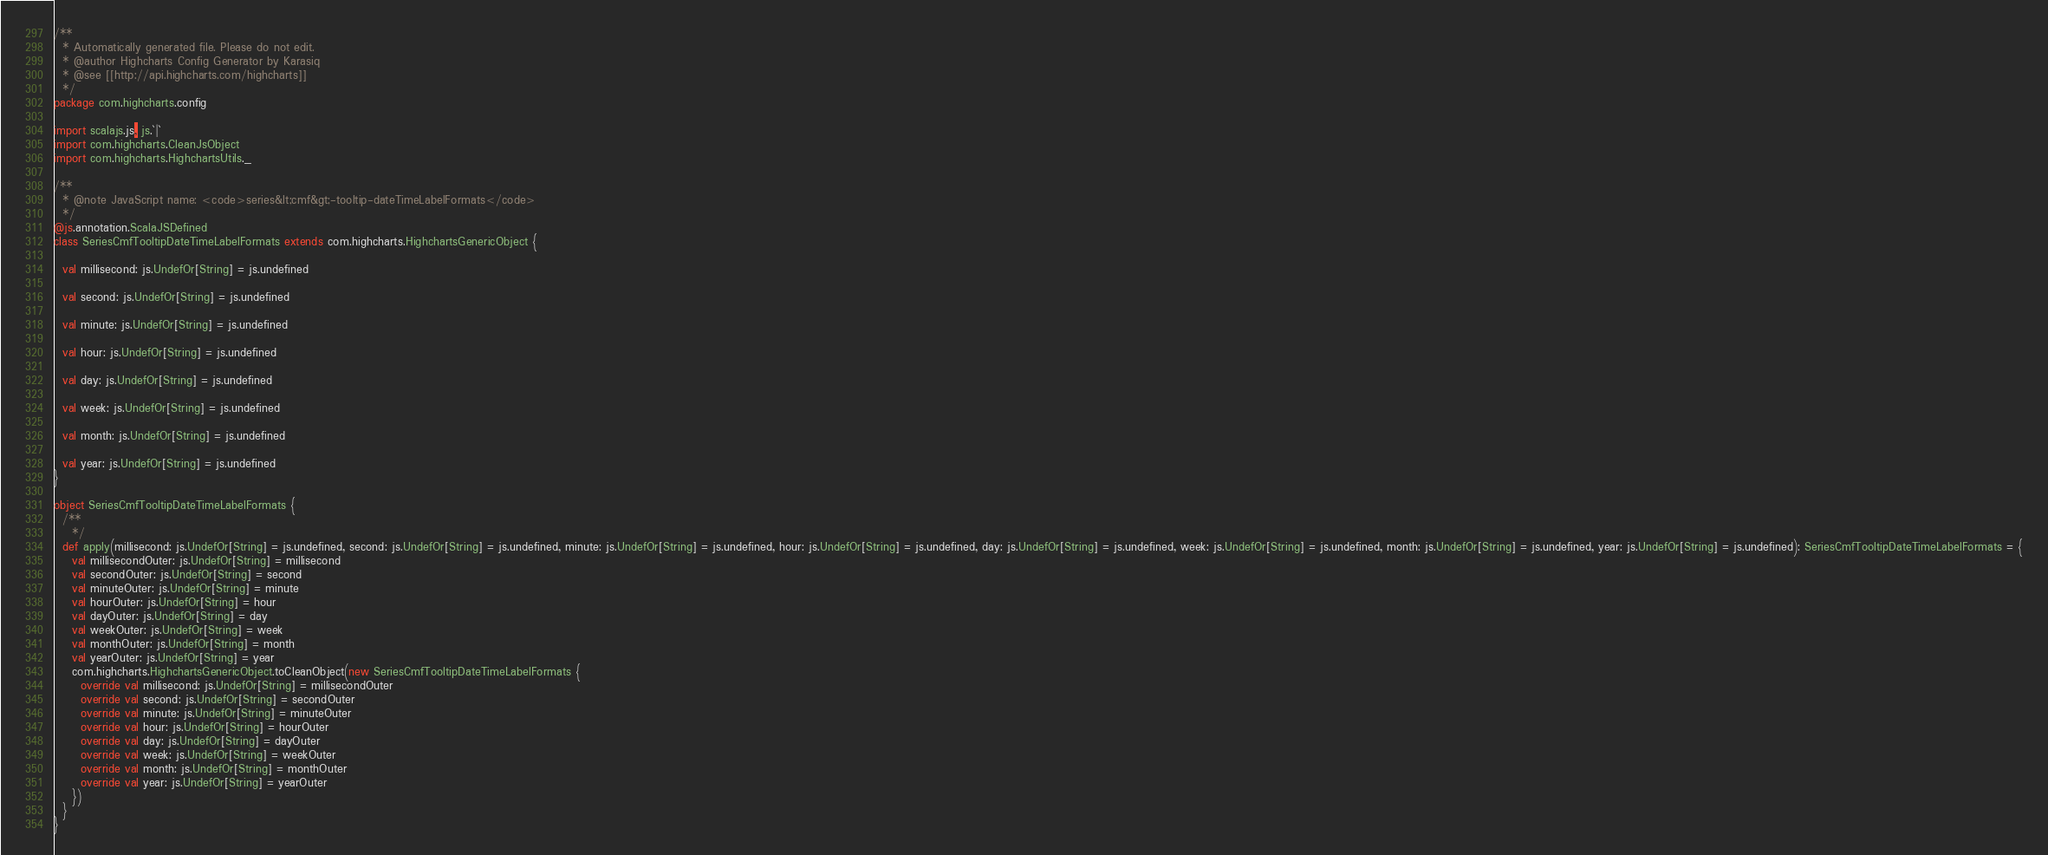Convert code to text. <code><loc_0><loc_0><loc_500><loc_500><_Scala_>/**
  * Automatically generated file. Please do not edit.
  * @author Highcharts Config Generator by Karasiq
  * @see [[http://api.highcharts.com/highcharts]]
  */
package com.highcharts.config

import scalajs.js, js.`|`
import com.highcharts.CleanJsObject
import com.highcharts.HighchartsUtils._

/**
  * @note JavaScript name: <code>series&lt;cmf&gt;-tooltip-dateTimeLabelFormats</code>
  */
@js.annotation.ScalaJSDefined
class SeriesCmfTooltipDateTimeLabelFormats extends com.highcharts.HighchartsGenericObject {

  val millisecond: js.UndefOr[String] = js.undefined

  val second: js.UndefOr[String] = js.undefined

  val minute: js.UndefOr[String] = js.undefined

  val hour: js.UndefOr[String] = js.undefined

  val day: js.UndefOr[String] = js.undefined

  val week: js.UndefOr[String] = js.undefined

  val month: js.UndefOr[String] = js.undefined

  val year: js.UndefOr[String] = js.undefined
}

object SeriesCmfTooltipDateTimeLabelFormats {
  /**
    */
  def apply(millisecond: js.UndefOr[String] = js.undefined, second: js.UndefOr[String] = js.undefined, minute: js.UndefOr[String] = js.undefined, hour: js.UndefOr[String] = js.undefined, day: js.UndefOr[String] = js.undefined, week: js.UndefOr[String] = js.undefined, month: js.UndefOr[String] = js.undefined, year: js.UndefOr[String] = js.undefined): SeriesCmfTooltipDateTimeLabelFormats = {
    val millisecondOuter: js.UndefOr[String] = millisecond
    val secondOuter: js.UndefOr[String] = second
    val minuteOuter: js.UndefOr[String] = minute
    val hourOuter: js.UndefOr[String] = hour
    val dayOuter: js.UndefOr[String] = day
    val weekOuter: js.UndefOr[String] = week
    val monthOuter: js.UndefOr[String] = month
    val yearOuter: js.UndefOr[String] = year
    com.highcharts.HighchartsGenericObject.toCleanObject(new SeriesCmfTooltipDateTimeLabelFormats {
      override val millisecond: js.UndefOr[String] = millisecondOuter
      override val second: js.UndefOr[String] = secondOuter
      override val minute: js.UndefOr[String] = minuteOuter
      override val hour: js.UndefOr[String] = hourOuter
      override val day: js.UndefOr[String] = dayOuter
      override val week: js.UndefOr[String] = weekOuter
      override val month: js.UndefOr[String] = monthOuter
      override val year: js.UndefOr[String] = yearOuter
    })
  }
}
</code> 